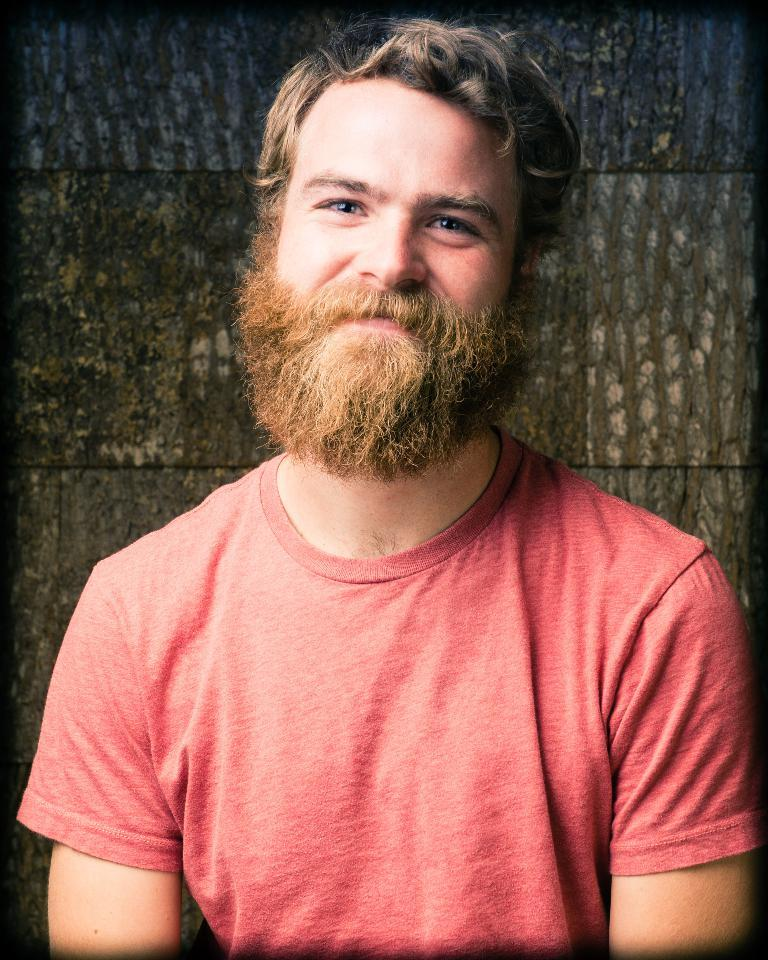Who or what is the main subject in the image? There is a person in the image. What is the person wearing? The person is wearing a red dress. What can be seen in the background of the image? There is a brown-colored wall in the background of the image. What type of fuel is the person using to power their vehicle in the image? There is no vehicle or fuel present in the image; it features a person wearing a red dress in front of a brown-colored wall. 